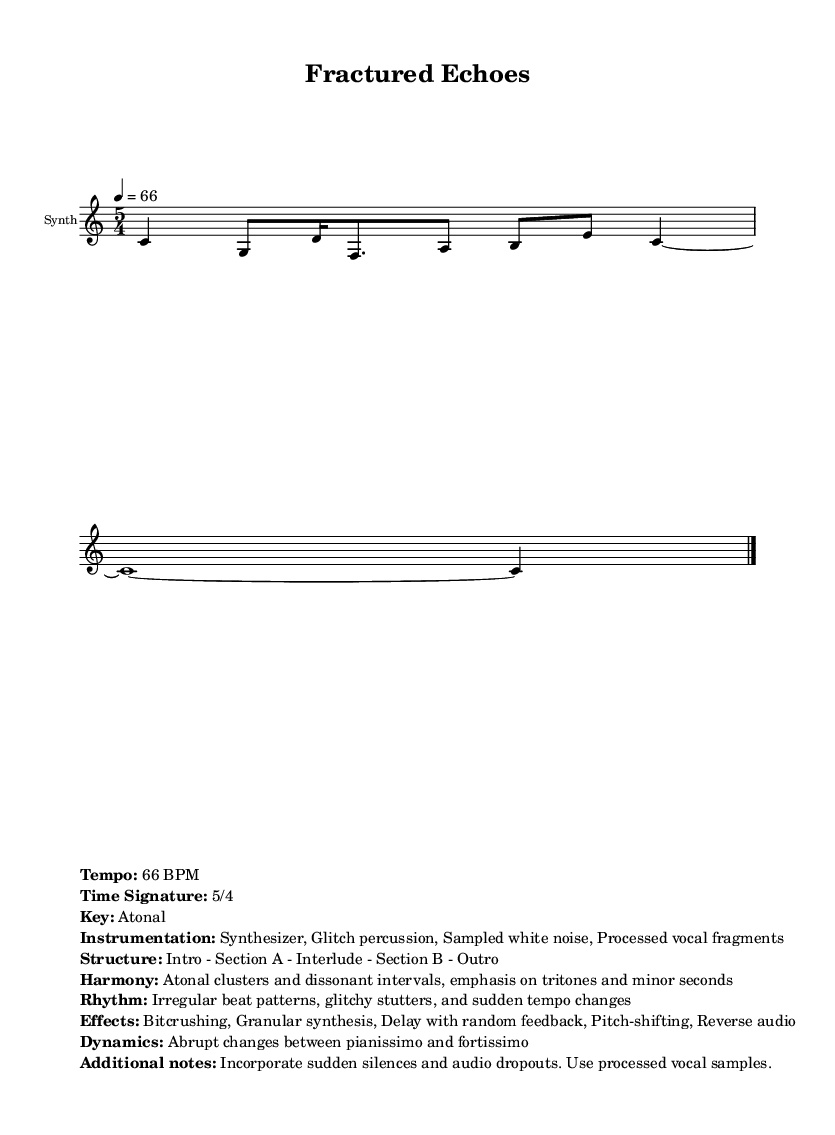What is the time signature of this music? The time signature is indicated at the beginning of the score, specified as 5/4. This means there are five beats in each measure, and a quarter note gets one beat.
Answer: 5/4 What is the tempo of this music? The tempo is indicated in the score with the marking '4 = 66'. This indicates that there are 66 beats per minute in the piece, dictating the speed of the music.
Answer: 66 BPM What is the key of this music? The key signature is explicitly mentioned as "Atonal" in the markup section of the score. This indicates that the piece does not adhere to a traditional major or minor key.
Answer: Atonal What type of percussion is used in this piece? The instrumentation section states "Glitch percussion," which refers to rhythmic components produced using digital sound manipulation techniques common in electronic music.
Answer: Glitch percussion How is the structure of this music arranged? The structure is provided in the markup, listed as "Intro - Section A - Interlude - Section B - Outro". This outlines the progression of the piece from the beginning to the end.
Answer: Intro - Section A - Interlude - Section B - Outro What kind of effects are incorporated in this music? The effects section details multiple audio processing techniques, including "Bitcrushing, Granular synthesis, Delay with random feedback, Pitch-shifting, Reverse audio." These are typical effects used in glitch and experimental electronic music.
Answer: Bitcrushing, Granular synthesis, Delay with random feedback, Pitch-shifting, Reverse audio 